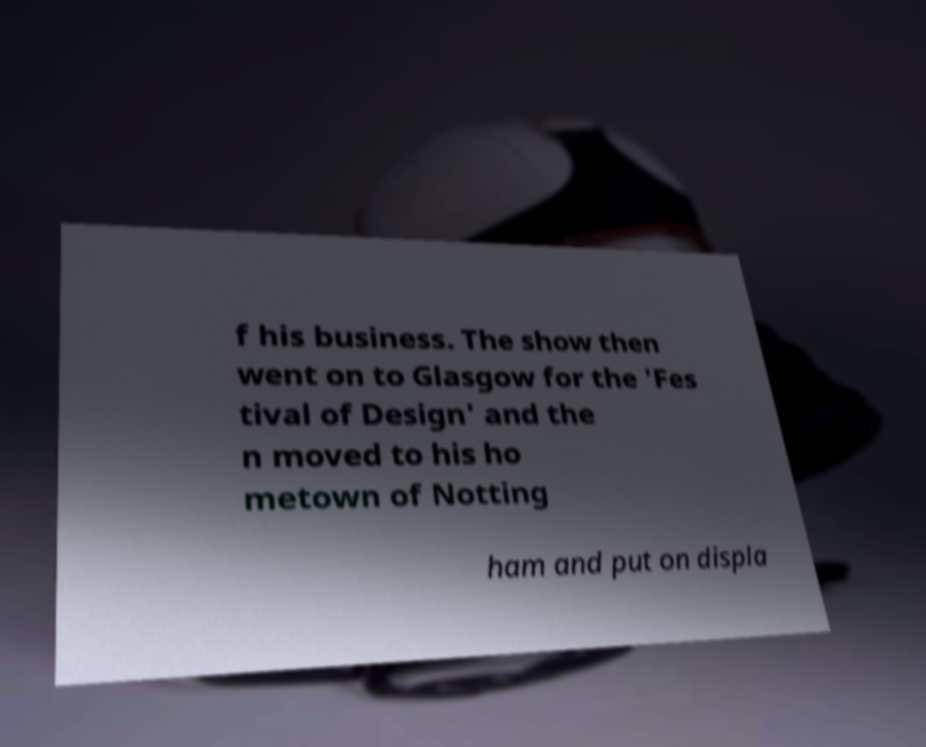I need the written content from this picture converted into text. Can you do that? f his business. The show then went on to Glasgow for the 'Fes tival of Design' and the n moved to his ho metown of Notting ham and put on displa 